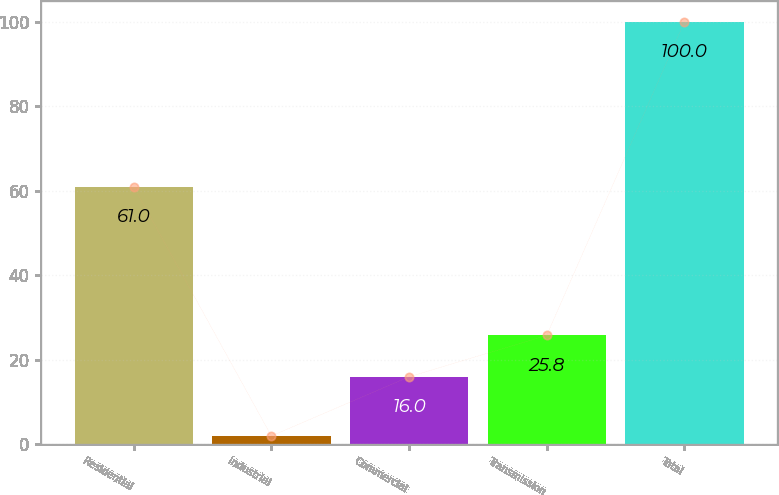Convert chart. <chart><loc_0><loc_0><loc_500><loc_500><bar_chart><fcel>Residential<fcel>Industrial<fcel>Commercial<fcel>Transmission<fcel>Total<nl><fcel>61<fcel>2<fcel>16<fcel>25.8<fcel>100<nl></chart> 